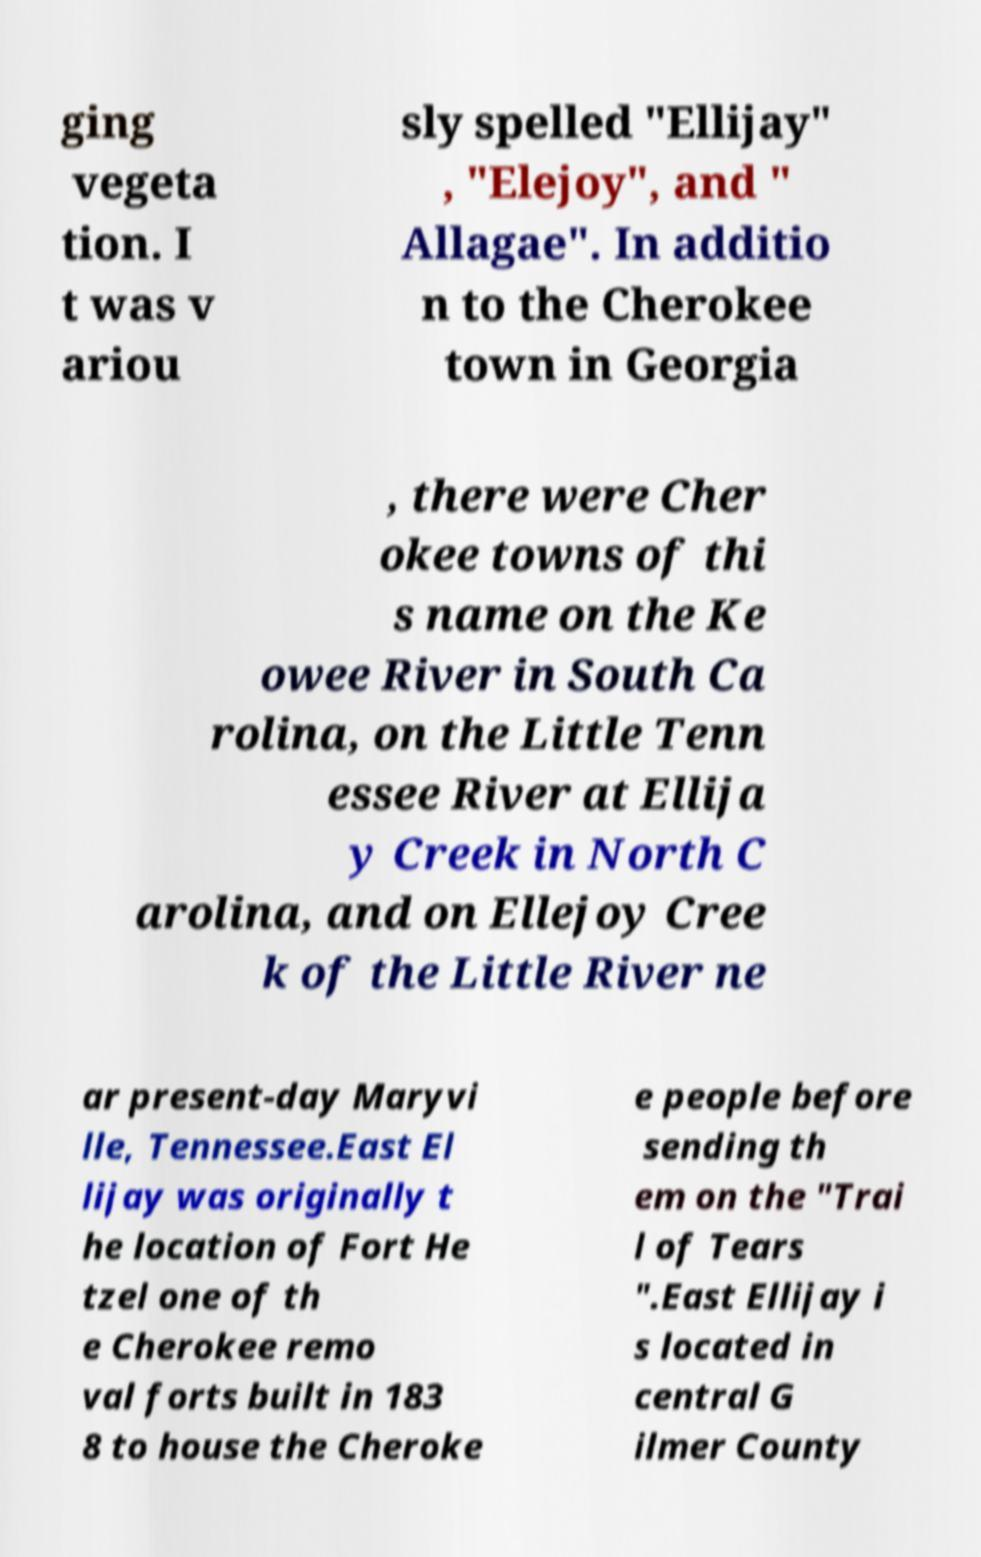Could you extract and type out the text from this image? ging vegeta tion. I t was v ariou sly spelled "Ellijay" , "Elejoy", and " Allagae". In additio n to the Cherokee town in Georgia , there were Cher okee towns of thi s name on the Ke owee River in South Ca rolina, on the Little Tenn essee River at Ellija y Creek in North C arolina, and on Ellejoy Cree k of the Little River ne ar present-day Maryvi lle, Tennessee.East El lijay was originally t he location of Fort He tzel one of th e Cherokee remo val forts built in 183 8 to house the Cheroke e people before sending th em on the "Trai l of Tears ".East Ellijay i s located in central G ilmer County 